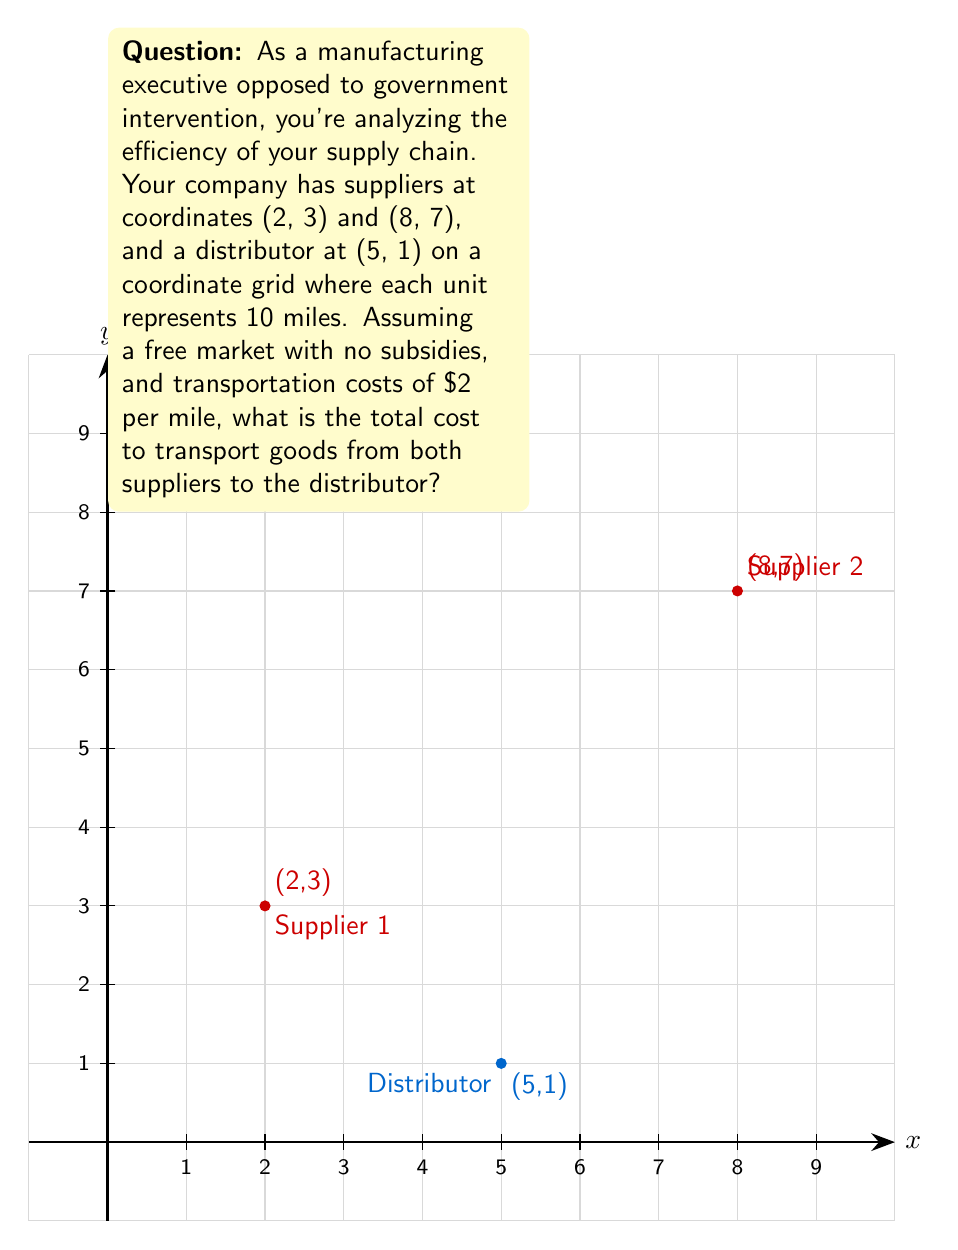Teach me how to tackle this problem. Let's approach this step-by-step:

1) First, we need to calculate the distances from each supplier to the distributor.

2) For Supplier 1 (2, 3) to Distributor (5, 1):
   Distance = $\sqrt{(x_2-x_1)^2 + (y_2-y_1)^2}$
             = $\sqrt{(5-2)^2 + (1-3)^2}$
             = $\sqrt{3^2 + (-2)^2}$
             = $\sqrt{9 + 4}$
             = $\sqrt{13}$

3) For Supplier 2 (8, 7) to Distributor (5, 1):
   Distance = $\sqrt{(x_2-x_1)^2 + (y_2-y_1)^2}$
             = $\sqrt{(5-8)^2 + (1-7)^2}$
             = $\sqrt{(-3)^2 + (-6)^2}$
             = $\sqrt{9 + 36}$
             = $\sqrt{45}$
             = $3\sqrt{5}$

4) Remember, each unit on the grid represents 10 miles. So we multiply our distances by 10:
   Supplier 1 to Distributor: $10\sqrt{13}$ miles
   Supplier 2 to Distributor: $30\sqrt{5}$ miles

5) The cost is $2 per mile, so we multiply each distance by 2:
   Cost from Supplier 1: $2 * 10\sqrt{13} = 20\sqrt{13}$ dollars
   Cost from Supplier 2: $2 * 30\sqrt{5} = 60\sqrt{5}$ dollars

6) Total cost is the sum of these two:
   Total Cost = $20\sqrt{13} + 60\sqrt{5}$ dollars
Answer: $20\sqrt{13} + 60\sqrt{5}$ dollars 